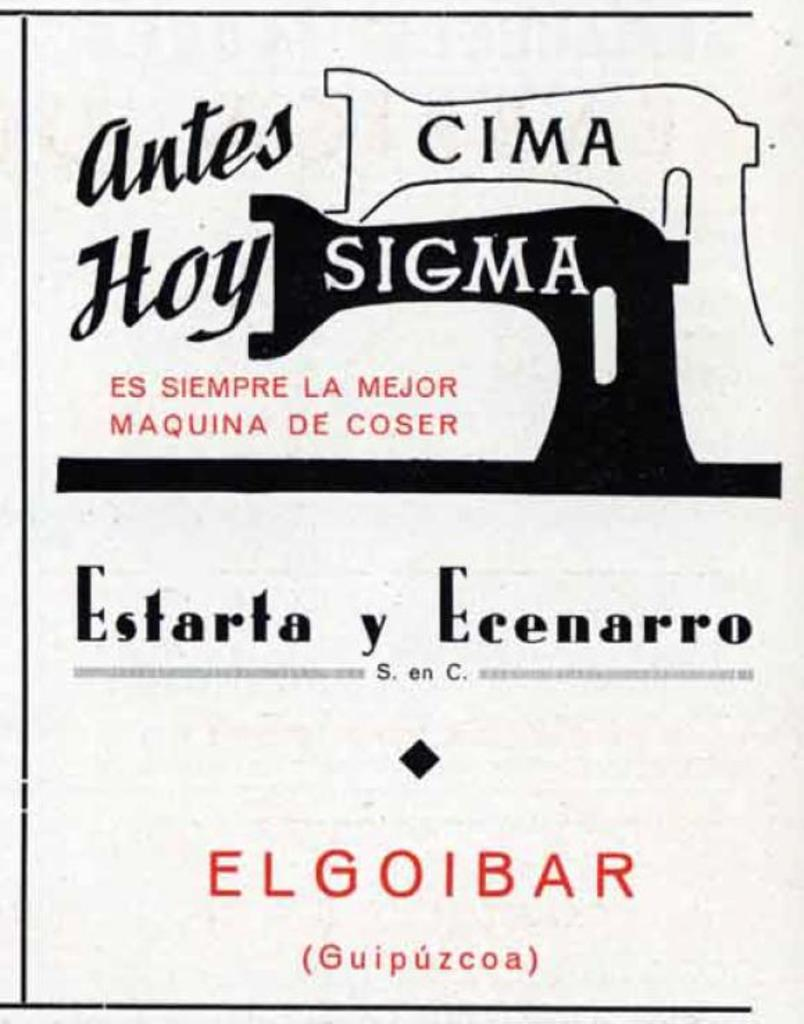<image>
Give a short and clear explanation of the subsequent image. an advertisement fo the cima sigma sewing machine in black and white. 